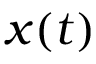<formula> <loc_0><loc_0><loc_500><loc_500>x ( t )</formula> 